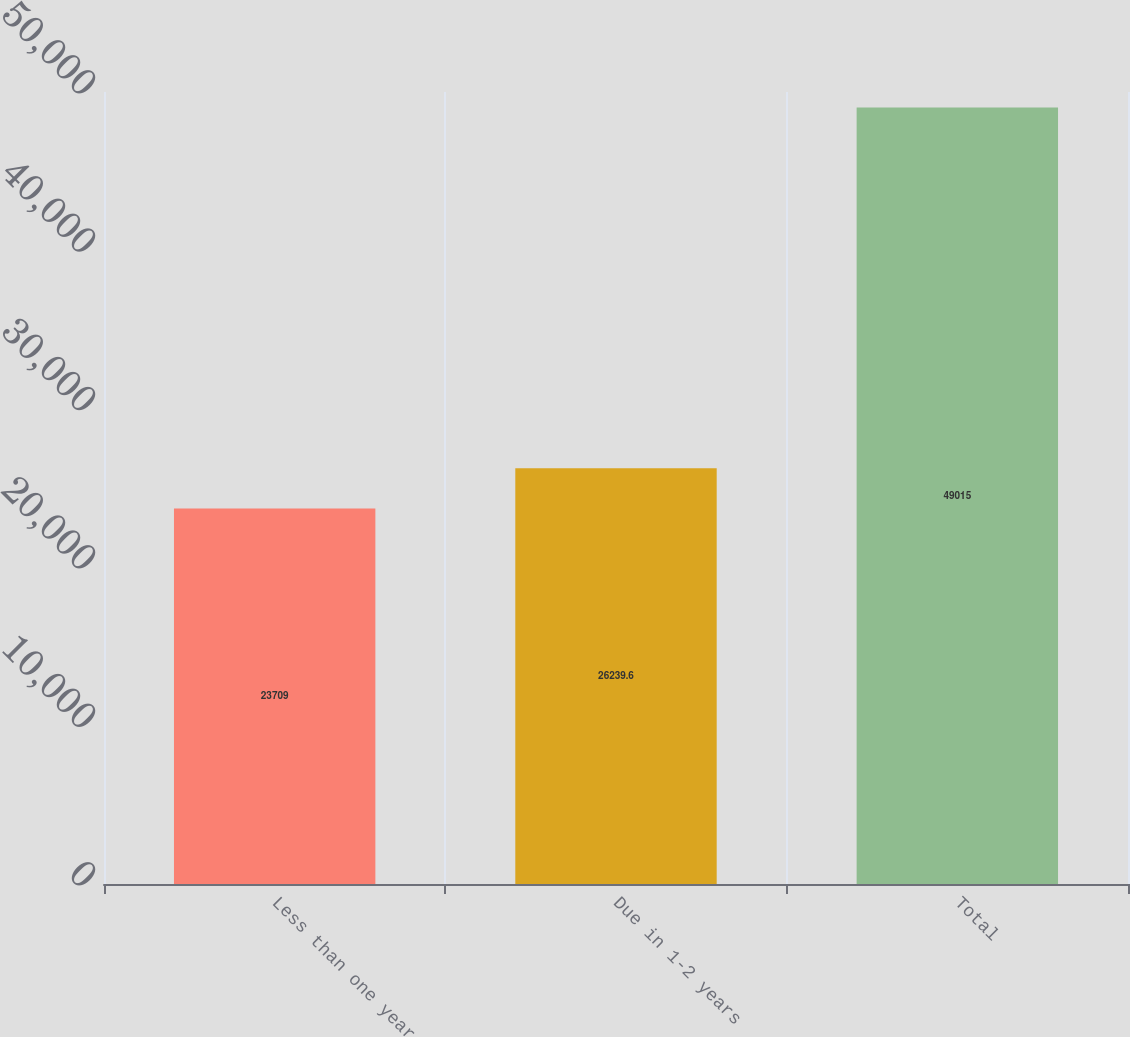Convert chart. <chart><loc_0><loc_0><loc_500><loc_500><bar_chart><fcel>Less than one year<fcel>Due in 1-2 years<fcel>Total<nl><fcel>23709<fcel>26239.6<fcel>49015<nl></chart> 